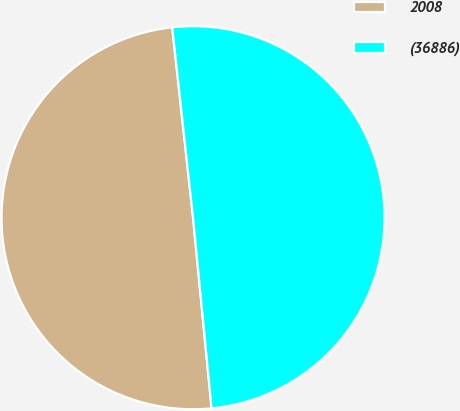<chart> <loc_0><loc_0><loc_500><loc_500><pie_chart><fcel>2008<fcel>(36886)<nl><fcel>49.81%<fcel>50.19%<nl></chart> 